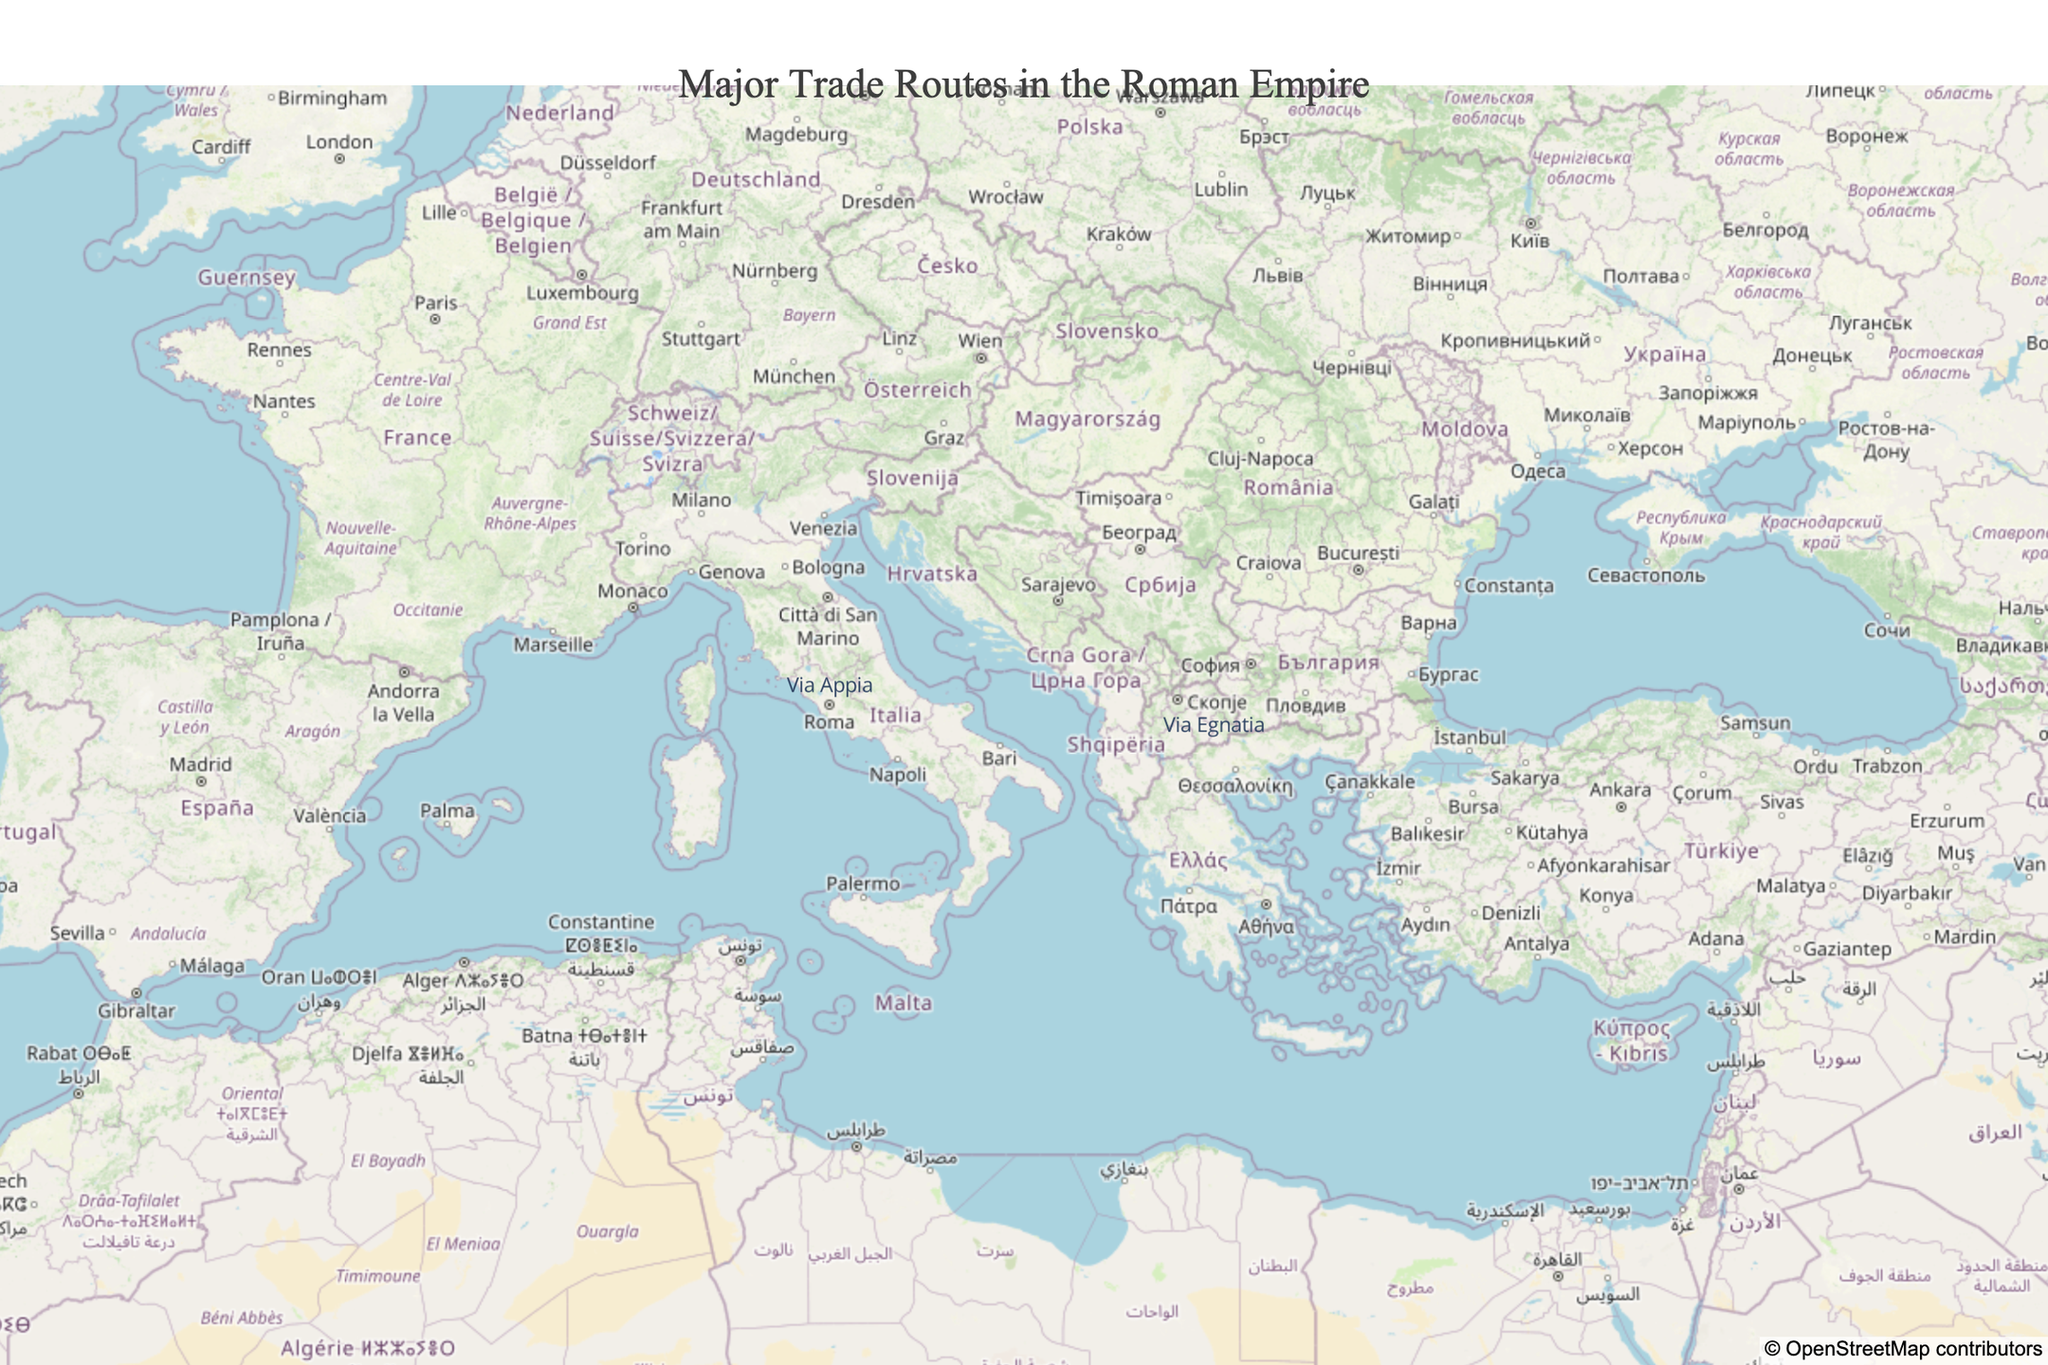What is the title of the figure? The title of the figure is positioned at the top and centered. It reads "Major Trade Routes in the Roman Empire".
Answer: Major Trade Routes in the Roman Empire What color are the markers used for the trade routes? The markers for the trade routes are indicated with an orange color. This is visually represented on the map with orange star symbols.
Answer: Orange How many major trade routes are shown on the map? By counting the number of labeled locations, we see two major trade routes on the map: Via Egnatia and Via Appia.
Answer: Two Which trade route is positioned further east? By comparing the longitudes of the locations, Via Egnatia (Longitude: 22.3964) is further east compared to Via Appia (Longitude: 12.5016).
Answer: Via Egnatia Are both trade routes described as 'Major Trade Route'? Yes, both locations listed in the hover text are described as 'Major Trade Route'.
Answer: Yes Which trade route is primarily within Italy? The hover text or annotation for Via Appia specifies that it handles various goods within Italy.
Answer: Via Appia What types of goods are exchanged on Via Egnatia? The hover text for Via Egnatia indicates that it handles various goods from East to West.
Answer: Various goods from East to West What is the latitude of Via Appia? By looking at the latitude values, Via Appia is positioned at latitude 41.8819.
Answer: 41.8819 Which trade route appears to connect different regions rather than within a single region? From the hover information, it is clear that Via Egnatia handles trade extending from East to West, implying it connects different regions rather than being confined within one region.
Answer: Via Egnatia Considering the zoom level and center location, does the map provide a detailed or broad view of the Roman Empire's trade routes? The map's center (Latitude: 41.5, Longitude: 17.5) and a zoom level of 4 offer a broad view that covers a significant portion of the Roman Empire, although detailed exploration may require further zooming.
Answer: Broad view 